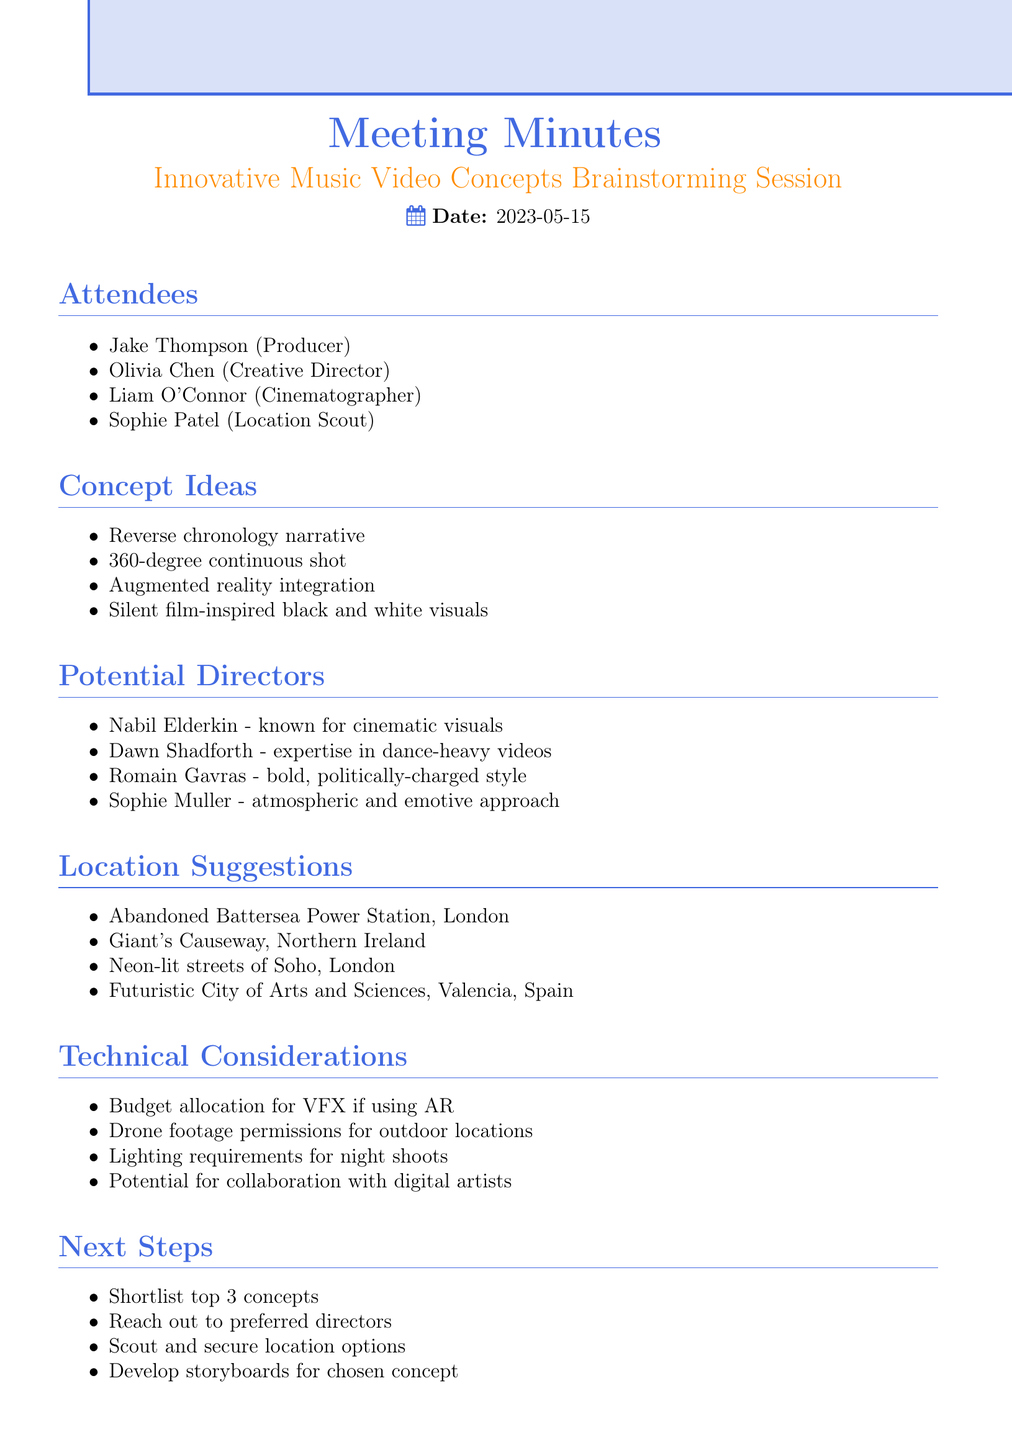what is the date of the meeting? The date of the meeting is mentioned at the beginning of the document.
Answer: 2023-05-15 who is the Creative Director? The attendees section lists the roles and names of participants, including the Creative Director.
Answer: Olivia Chen what is one concept idea discussed? The concept ideas section includes multiple points of discussion.
Answer: Reverse chronology narrative name one potential director mentioned in the meeting. The potential directors section lists several notable directors.
Answer: Nabil Elderkin where is one suggested location for filming? The location suggestions section highlights several potential filming sites.
Answer: Abandoned Battersea Power Station, London what is one technical consideration noted? Technical considerations are summarized in the relevant section of the document.
Answer: Budget allocation for VFX if using AR how many potential directors were proposed? The number of potential directors can be counted from the list provided in the document.
Answer: 4 what is the next step after shortlisting top concepts? The next steps section outlines the actions to be taken following the concept shortlist.
Answer: Reach out to preferred directors which location is listed in Spain? The location suggestions section includes geographical information about the suggested sites.
Answer: Futuristic City of Arts and Sciences, Valencia, Spain 